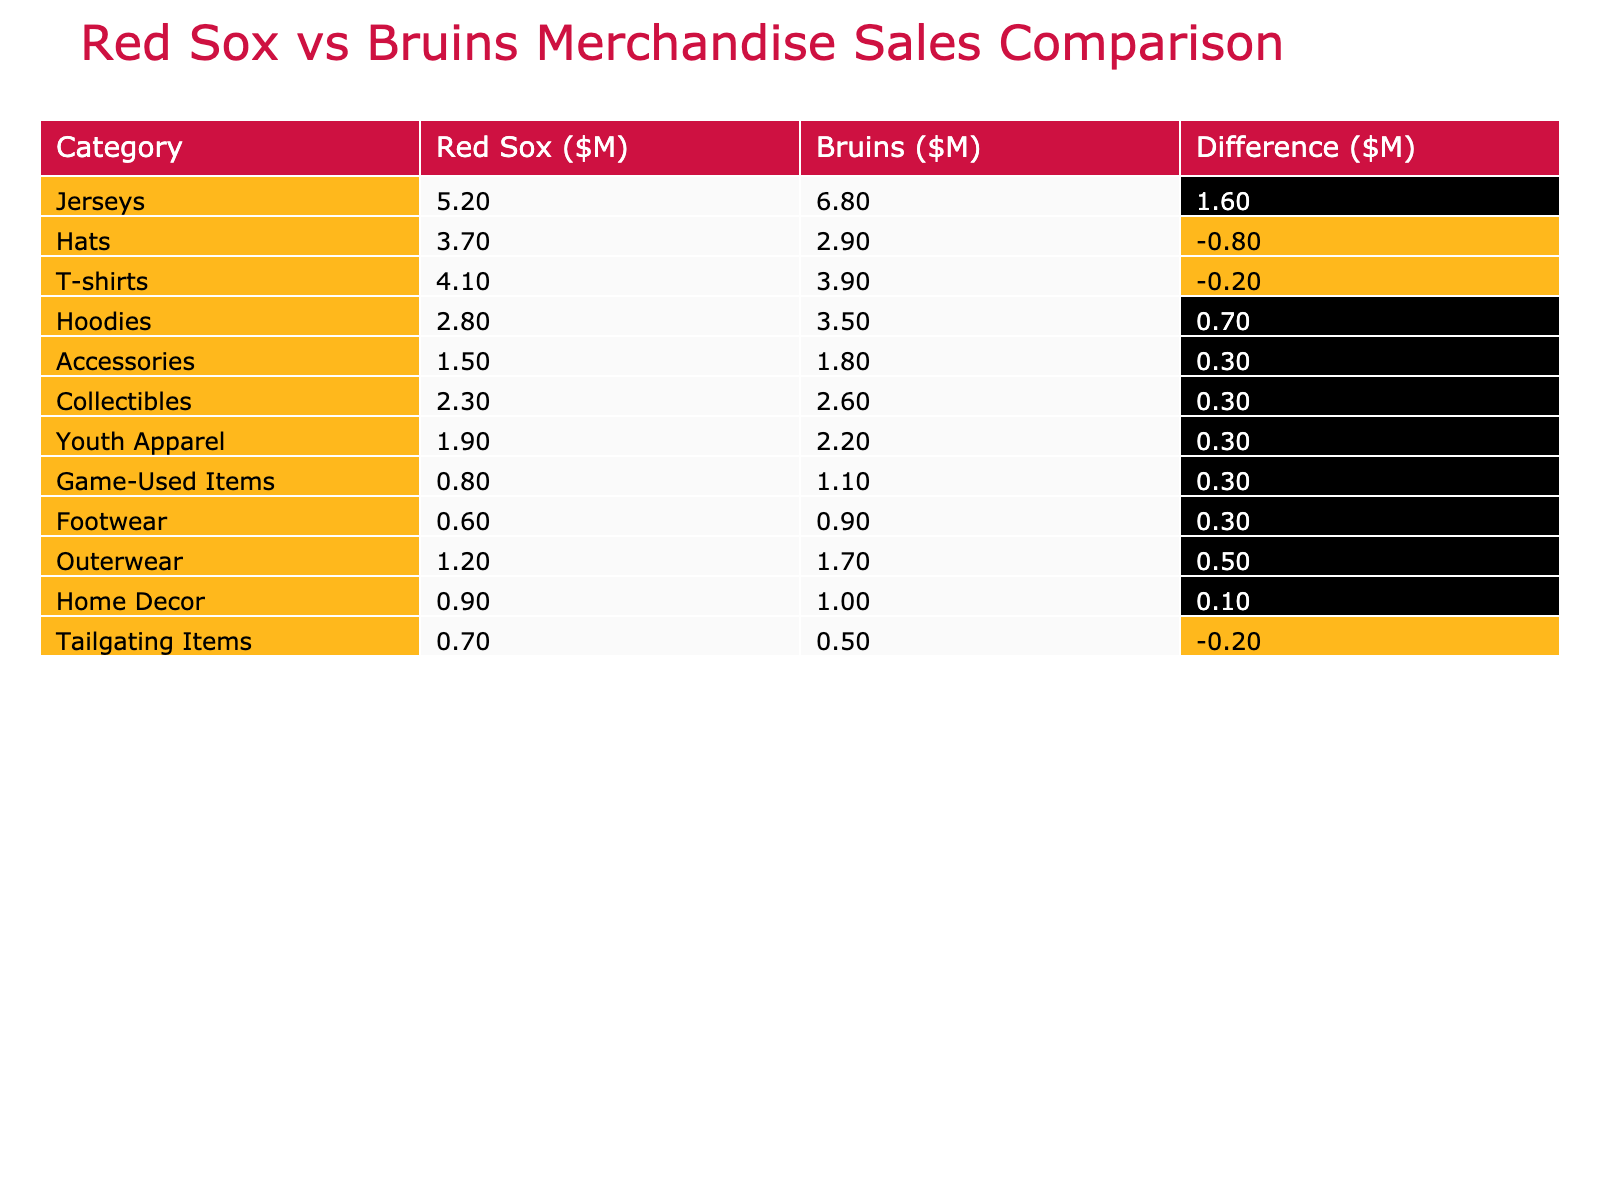What was the merchandise sales total for the Bruins? To find the total merchandise sales for the Bruins, we sum up all the values in the Bruins column: 6.8 + 2.9 + 3.9 + 3.5 + 1.8 + 2.6 + 2.2 + 1.1 + 0.9 + 1.7 + 1.0 + 0.5 = 28.1 million dollars.
Answer: 28.1M Which product category sold the most for the Red Sox? The product categories for the Red Sox and their sales are listed. Comparing these values, Jerseys sold the highest at 5.2 million dollars.
Answer: Jerseys Did the Red Sox sell more in total than the Bruins? To determine this, we need to calculate the total sales for both teams. The totals are: Red Sox 22.4 million and Bruins 28.1 million. Since 22.4 is less than 28.1, the statement is false.
Answer: No What is the difference in sales between the Bruins and Red Sox for T-shirts? The sales of T-shirts for Bruins is 3.9 million and for Red Sox is 4.1 million. The difference is 3.9 - 4.1 = -0.2 million, indicating that the Red Sox sold 0.2 million more than the Bruins.
Answer: -0.2M How much more did the Bruins sell in Jerseys compared to the Red Sox? The Bruins sold jerseys amounting to 6.8 million while the Red Sox sold 5.2 million. The difference is 6.8 - 5.2 = 1.6 million, meaning the Bruins sold 1.6 million more.
Answer: 1.6M Which category saw the least sales for the Red Sox? By examining the sales values in the Red Sox column, Footwear shows the least at 0.6 million dollars.
Answer: Footwear Is it true that the Bruins sold more in Collectibles than the Red Sox? The Bruins sold 2.6 million in Collectibles while the Red Sox sold 2.3 million. Since 2.6 is greater than 2.3, the statement is true.
Answer: Yes What is the total sales for Hats in both teams combined? For Hats, the Red Sox sold 3.7 million and the Bruins sold 2.9 million. Adding these together gives us 3.7 + 2.9 = 6.6 million total sales for Hats.
Answer: 6.6M Which team had higher sales in Accessories and by how much? The Red Sox sold 1.5 million in Accessories while the Bruins sold 1.8 million. The Bruins had higher sales by 1.8 - 1.5 = 0.3 million dollars.
Answer: 0.3M 